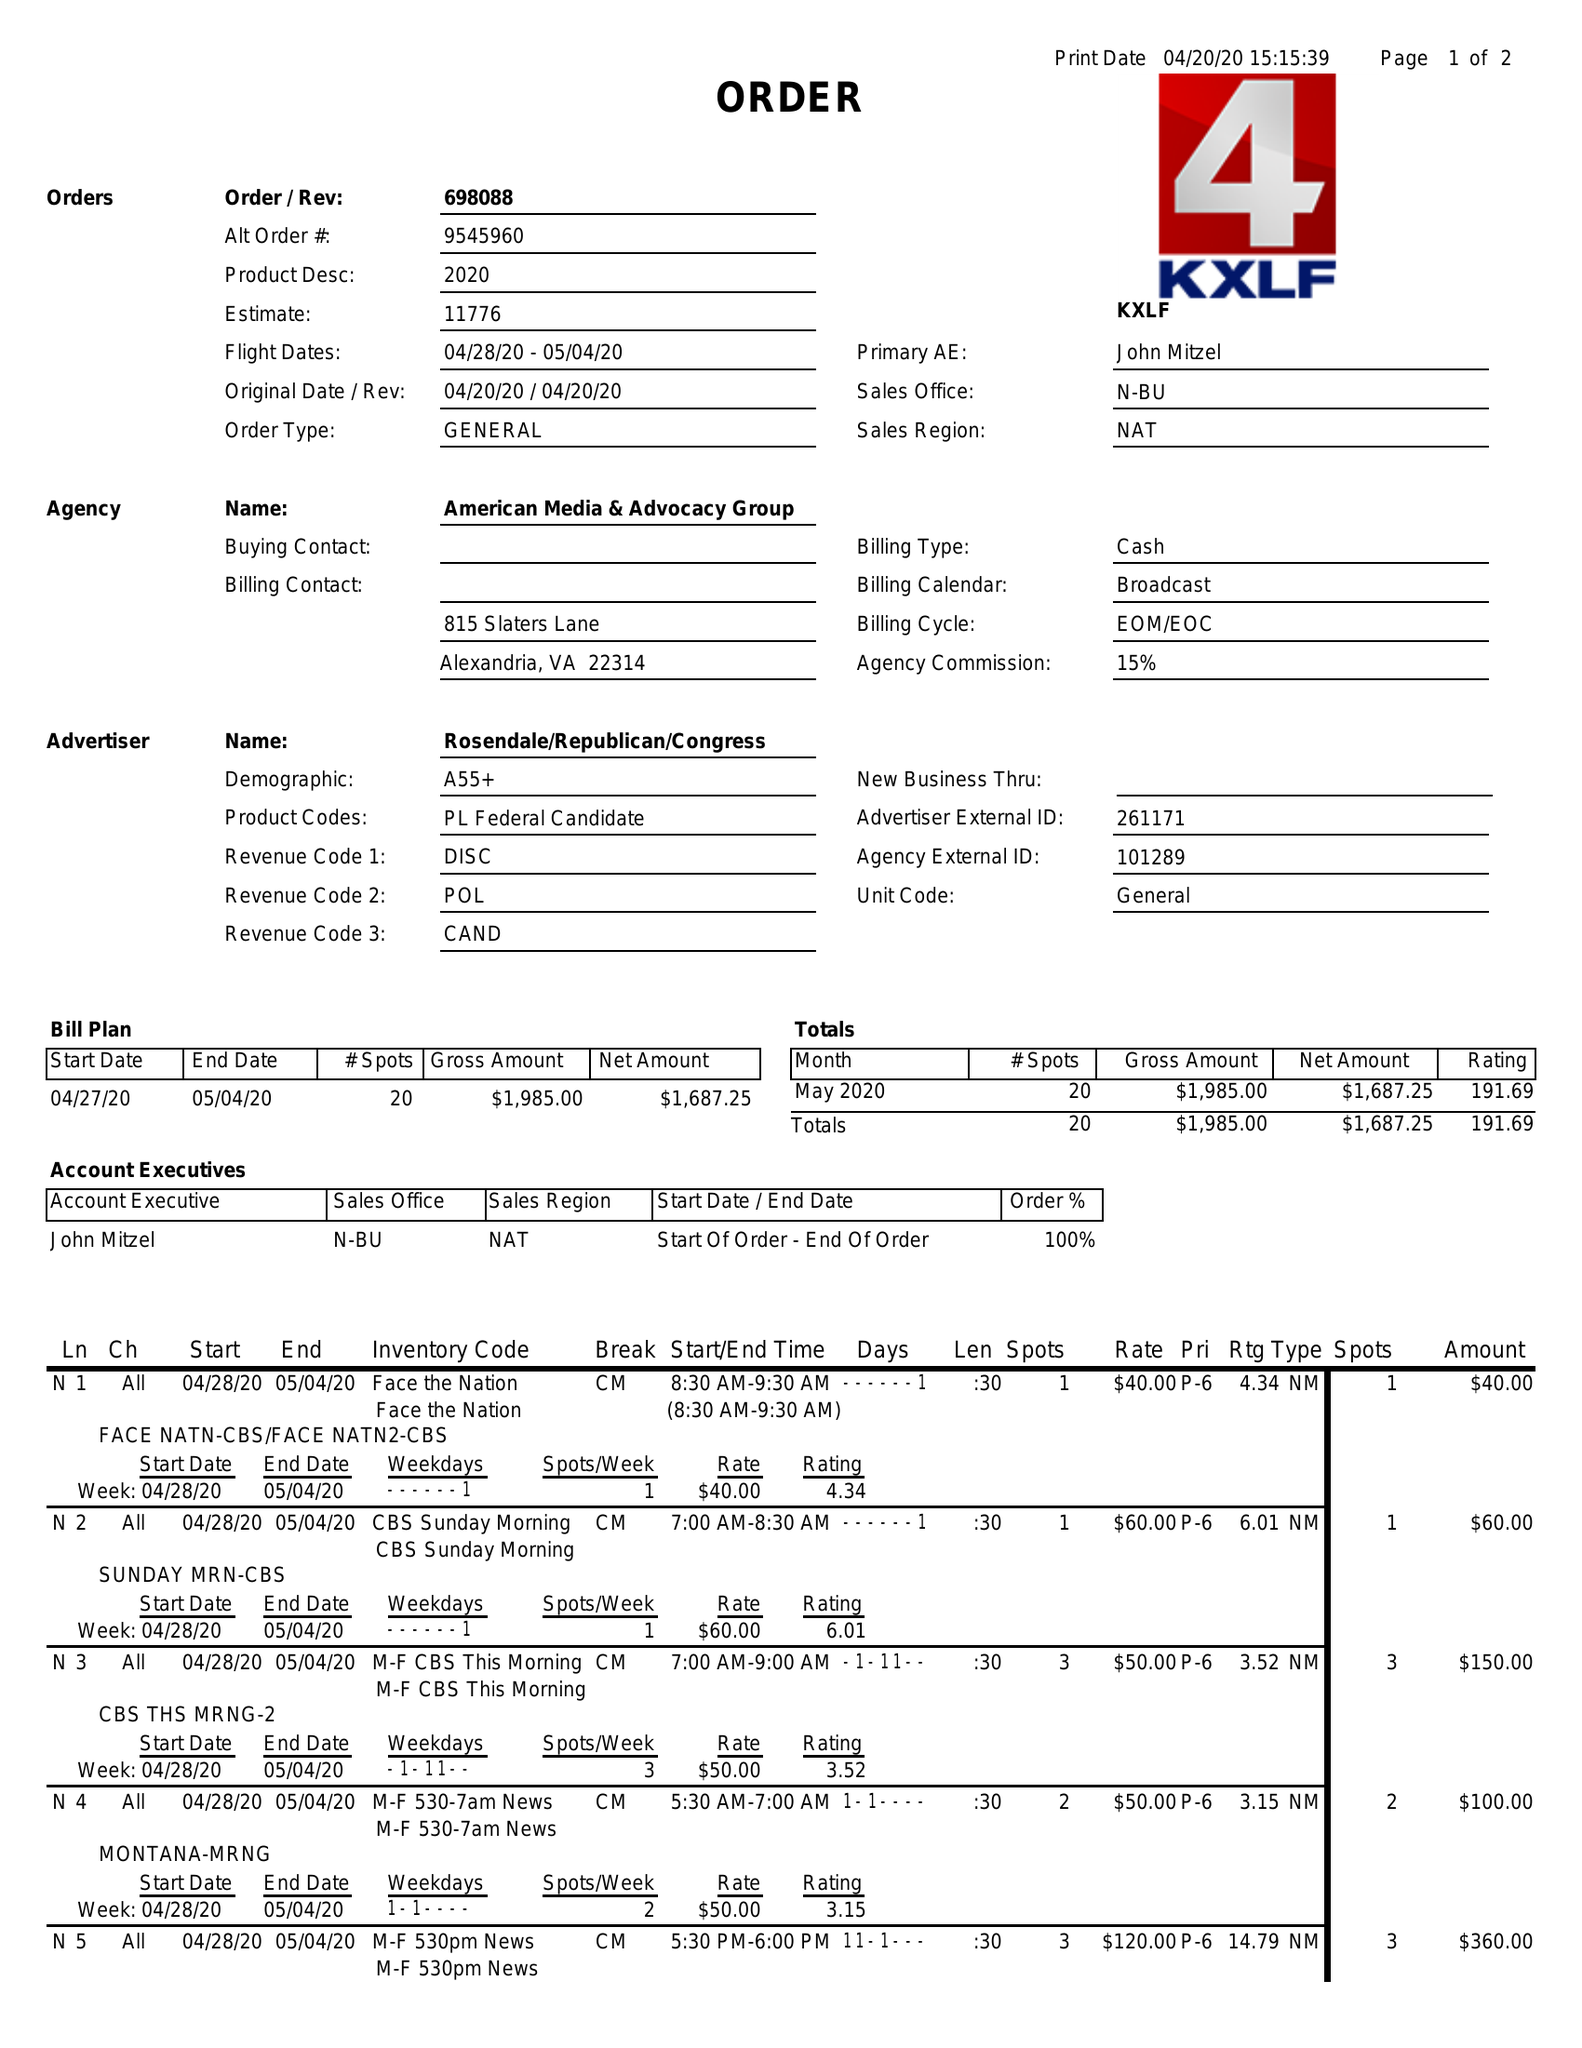What is the value for the contract_num?
Answer the question using a single word or phrase. 69808804 